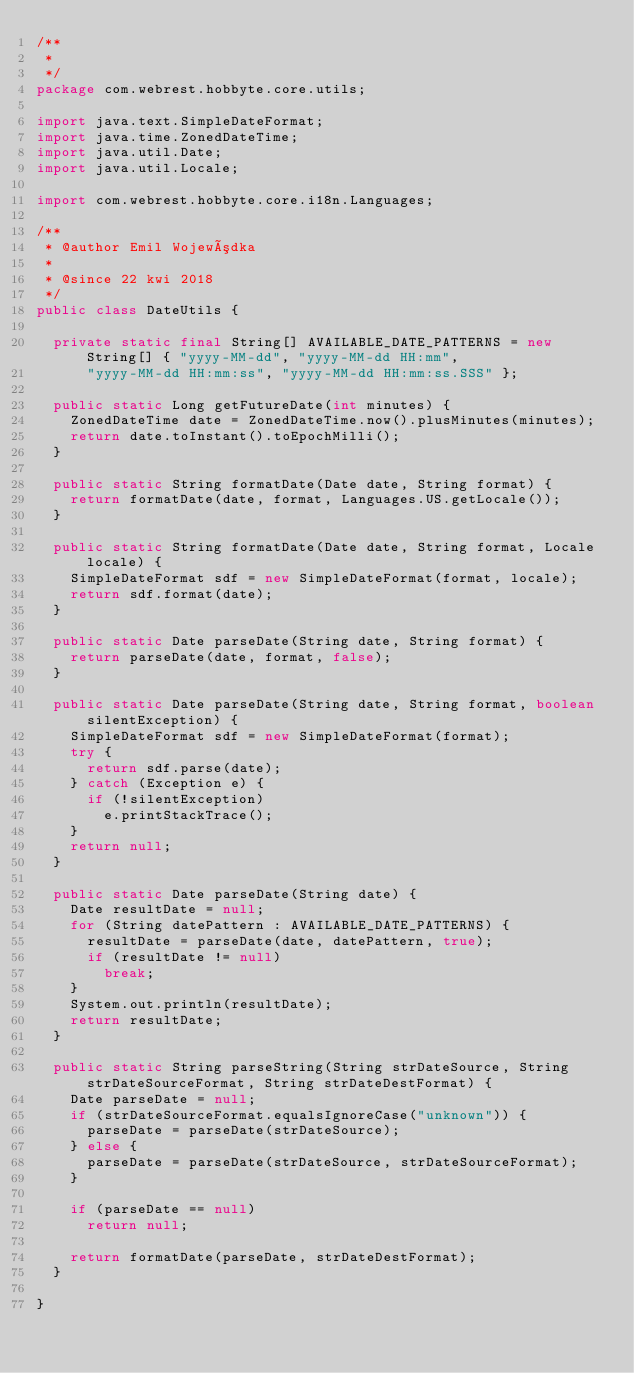<code> <loc_0><loc_0><loc_500><loc_500><_Java_>/**
 * 
 */
package com.webrest.hobbyte.core.utils;

import java.text.SimpleDateFormat;
import java.time.ZonedDateTime;
import java.util.Date;
import java.util.Locale;

import com.webrest.hobbyte.core.i18n.Languages;

/**
 * @author Emil Wojewódka
 *
 * @since 22 kwi 2018
 */
public class DateUtils {

	private static final String[] AVAILABLE_DATE_PATTERNS = new String[] { "yyyy-MM-dd", "yyyy-MM-dd HH:mm",
			"yyyy-MM-dd HH:mm:ss", "yyyy-MM-dd HH:mm:ss.SSS" };

	public static Long getFutureDate(int minutes) {
		ZonedDateTime date = ZonedDateTime.now().plusMinutes(minutes);
		return date.toInstant().toEpochMilli();
	}

	public static String formatDate(Date date, String format) {
		return formatDate(date, format, Languages.US.getLocale());
	}

	public static String formatDate(Date date, String format, Locale locale) {
		SimpleDateFormat sdf = new SimpleDateFormat(format, locale);
		return sdf.format(date);
	}

	public static Date parseDate(String date, String format) {
		return parseDate(date, format, false);
	}

	public static Date parseDate(String date, String format, boolean silentException) {
		SimpleDateFormat sdf = new SimpleDateFormat(format);
		try {
			return sdf.parse(date);
		} catch (Exception e) {
			if (!silentException)
				e.printStackTrace();
		}
		return null;
	}

	public static Date parseDate(String date) {
		Date resultDate = null;
		for (String datePattern : AVAILABLE_DATE_PATTERNS) {
			resultDate = parseDate(date, datePattern, true);
			if (resultDate != null)
				break;
		}
		System.out.println(resultDate);
		return resultDate;
	}

	public static String parseString(String strDateSource, String strDateSourceFormat, String strDateDestFormat) {
		Date parseDate = null;
		if (strDateSourceFormat.equalsIgnoreCase("unknown")) {
			parseDate = parseDate(strDateSource);
		} else {
			parseDate = parseDate(strDateSource, strDateSourceFormat);
		}

		if (parseDate == null)
			return null;

		return formatDate(parseDate, strDateDestFormat);
	}

}
</code> 